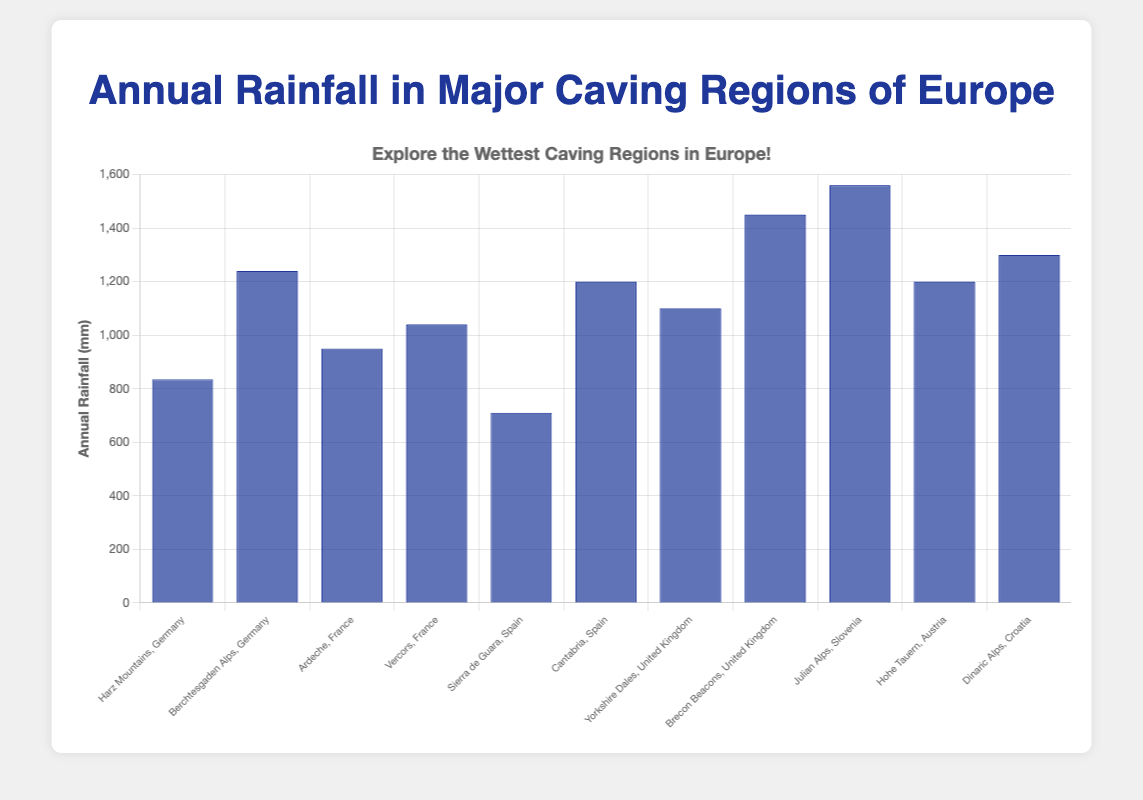Which region has the highest annual rainfall? The bar associated with "Julian Alps, Slovenia" is the tallest in the chart, indicating the highest annual rainfall.
Answer: Julian Alps, Slovenia Which region has the lowest annual rainfall? The bar associated with "Sierra de Guara, Spain" is the shortest in the chart, indicating the lowest annual rainfall.
Answer: Sierra de Guara, Spain Compare the annual rainfall between the Harz Mountains in Germany and the Berchtesgaden Alps in Germany. Which region is wetter? By comparing the heights of the bars, the Berchtesgaden Alps has a taller bar than the Harz Mountains, indicating a higher annual rainfall.
Answer: Berchtesgaden Alps What is the average annual rainfall of the regions in France? France has two regions, Ardeche (950 mm) and Vercors (1040 mm). The average is calculated as (950 + 1040) / 2 = 995 mm.
Answer: 995 mm Which region in the United Kingdom receives more rainfall, Yorkshire Dales or Brecon Beacons? Comparing the bar heights, Brecon Beacons has a taller bar than Yorkshire Dales, indicating higher annual rainfall.
Answer: Brecon Beacons What's the difference in annual rainfall between the Julian Alps, Slovenia and the Dinaric Alps, Croatia? Julian Alps (1560 mm) and Dinaric Alps (1300 mm). The difference is 1560 - 1300 = 260 mm.
Answer: 260 mm How much more rainfall does the Brecon Beacons in the United Kingdom receive compared to the Sierra de Guara in Spain? Brecon Beacons (1450 mm) and Sierra de Guara (710 mm). The difference is 1450 - 710 = 740 mm.
Answer: 740 mm What is the total annual rainfall for the regions in Germany? Germany has two regions: Harz Mountains (835 mm) and Berchtesgaden Alps (1240 mm). The total annual rainfall is 835 + 1240 = 2075 mm.
Answer: 2075 mm What is the annual rainfall range (difference between the highest and lowest values) in the dataset? The highest annual rainfall is in Julian Alps (1560 mm) and the lowest is in Sierra de Guara (710 mm). The range is 1560 - 710 = 850 mm.
Answer: 850 mm 